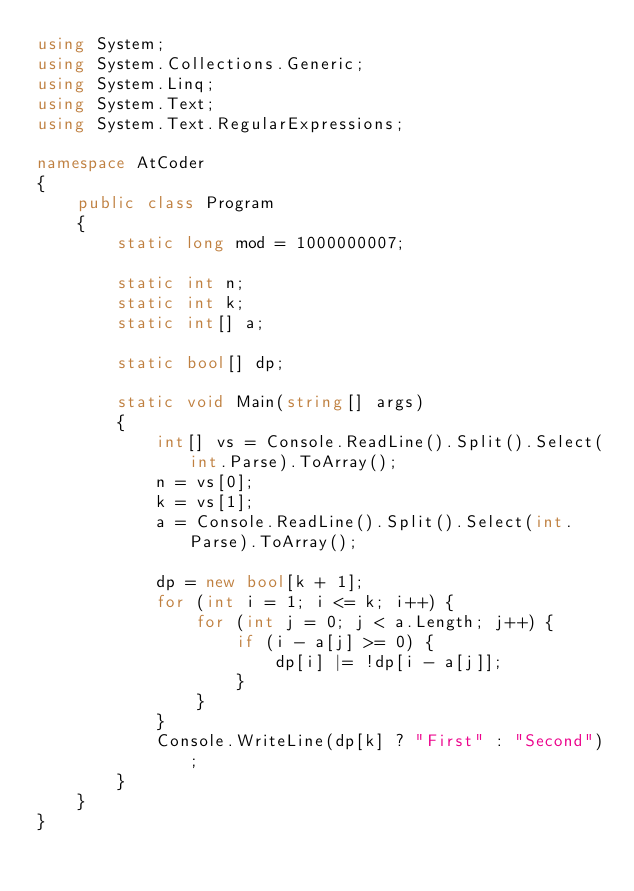<code> <loc_0><loc_0><loc_500><loc_500><_C#_>using System;
using System.Collections.Generic;
using System.Linq;
using System.Text;
using System.Text.RegularExpressions;

namespace AtCoder
{
	public class Program
	{
		static long mod = 1000000007;

		static int n;
		static int k;
		static int[] a;

		static bool[] dp;

		static void Main(string[] args)
		{
			int[] vs = Console.ReadLine().Split().Select(int.Parse).ToArray();
			n = vs[0];
			k = vs[1];
			a = Console.ReadLine().Split().Select(int.Parse).ToArray();

			dp = new bool[k + 1];
			for (int i = 1; i <= k; i++) {
				for (int j = 0; j < a.Length; j++) {
					if (i - a[j] >= 0) {
						dp[i] |= !dp[i - a[j]];
					}
				}
			}
			Console.WriteLine(dp[k] ? "First" : "Second");
		}
	}
}</code> 